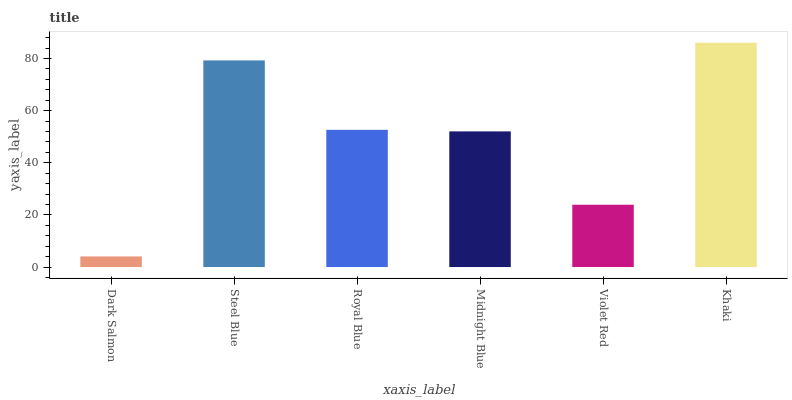Is Dark Salmon the minimum?
Answer yes or no. Yes. Is Khaki the maximum?
Answer yes or no. Yes. Is Steel Blue the minimum?
Answer yes or no. No. Is Steel Blue the maximum?
Answer yes or no. No. Is Steel Blue greater than Dark Salmon?
Answer yes or no. Yes. Is Dark Salmon less than Steel Blue?
Answer yes or no. Yes. Is Dark Salmon greater than Steel Blue?
Answer yes or no. No. Is Steel Blue less than Dark Salmon?
Answer yes or no. No. Is Royal Blue the high median?
Answer yes or no. Yes. Is Midnight Blue the low median?
Answer yes or no. Yes. Is Khaki the high median?
Answer yes or no. No. Is Dark Salmon the low median?
Answer yes or no. No. 